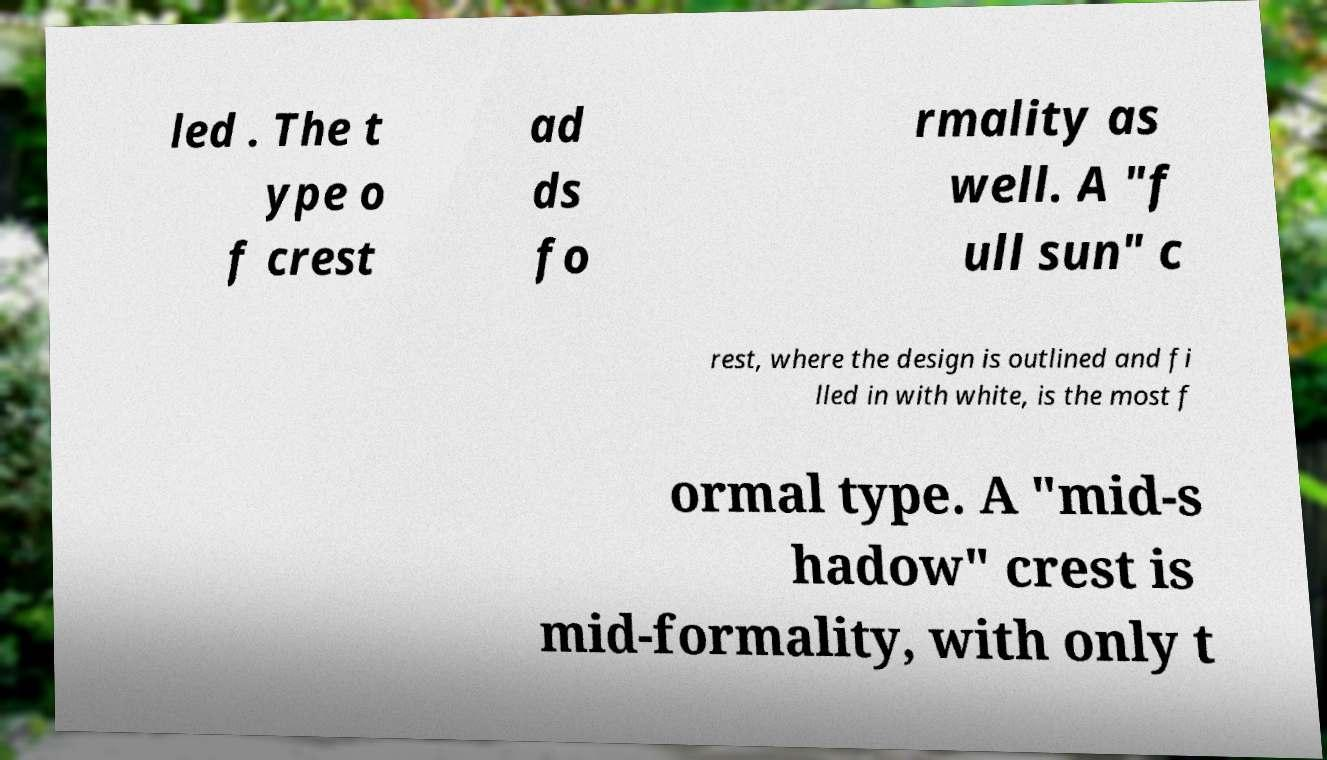There's text embedded in this image that I need extracted. Can you transcribe it verbatim? led . The t ype o f crest ad ds fo rmality as well. A "f ull sun" c rest, where the design is outlined and fi lled in with white, is the most f ormal type. A "mid-s hadow" crest is mid-formality, with only t 